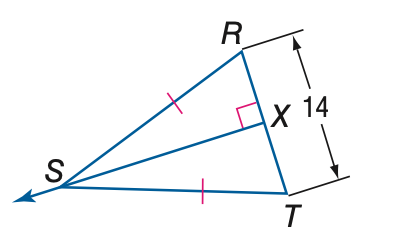Answer the mathemtical geometry problem and directly provide the correct option letter.
Question: Find the measure of X T.
Choices: A: 3.5 B: 7 C: 14 D: 28 B 